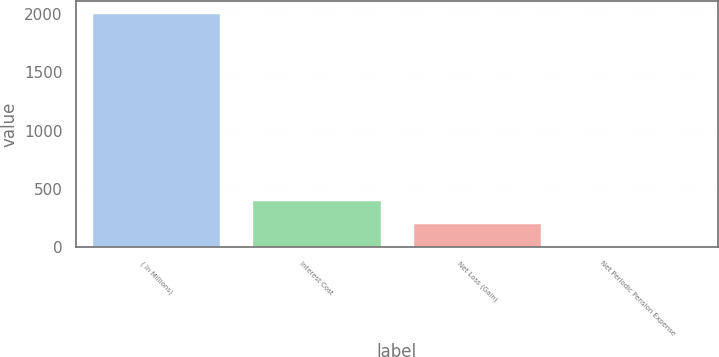Convert chart. <chart><loc_0><loc_0><loc_500><loc_500><bar_chart><fcel>( In Millions)<fcel>Interest Cost<fcel>Net Loss (Gain)<fcel>Net Periodic Pension Expense<nl><fcel>2015<fcel>404.04<fcel>202.67<fcel>1.3<nl></chart> 